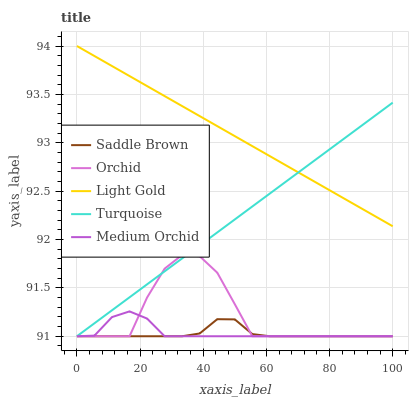Does Saddle Brown have the minimum area under the curve?
Answer yes or no. Yes. Does Light Gold have the maximum area under the curve?
Answer yes or no. Yes. Does Medium Orchid have the minimum area under the curve?
Answer yes or no. No. Does Medium Orchid have the maximum area under the curve?
Answer yes or no. No. Is Light Gold the smoothest?
Answer yes or no. Yes. Is Orchid the roughest?
Answer yes or no. Yes. Is Medium Orchid the smoothest?
Answer yes or no. No. Is Medium Orchid the roughest?
Answer yes or no. No. Does Turquoise have the lowest value?
Answer yes or no. Yes. Does Light Gold have the lowest value?
Answer yes or no. No. Does Light Gold have the highest value?
Answer yes or no. Yes. Does Medium Orchid have the highest value?
Answer yes or no. No. Is Medium Orchid less than Light Gold?
Answer yes or no. Yes. Is Light Gold greater than Saddle Brown?
Answer yes or no. Yes. Does Orchid intersect Turquoise?
Answer yes or no. Yes. Is Orchid less than Turquoise?
Answer yes or no. No. Is Orchid greater than Turquoise?
Answer yes or no. No. Does Medium Orchid intersect Light Gold?
Answer yes or no. No. 